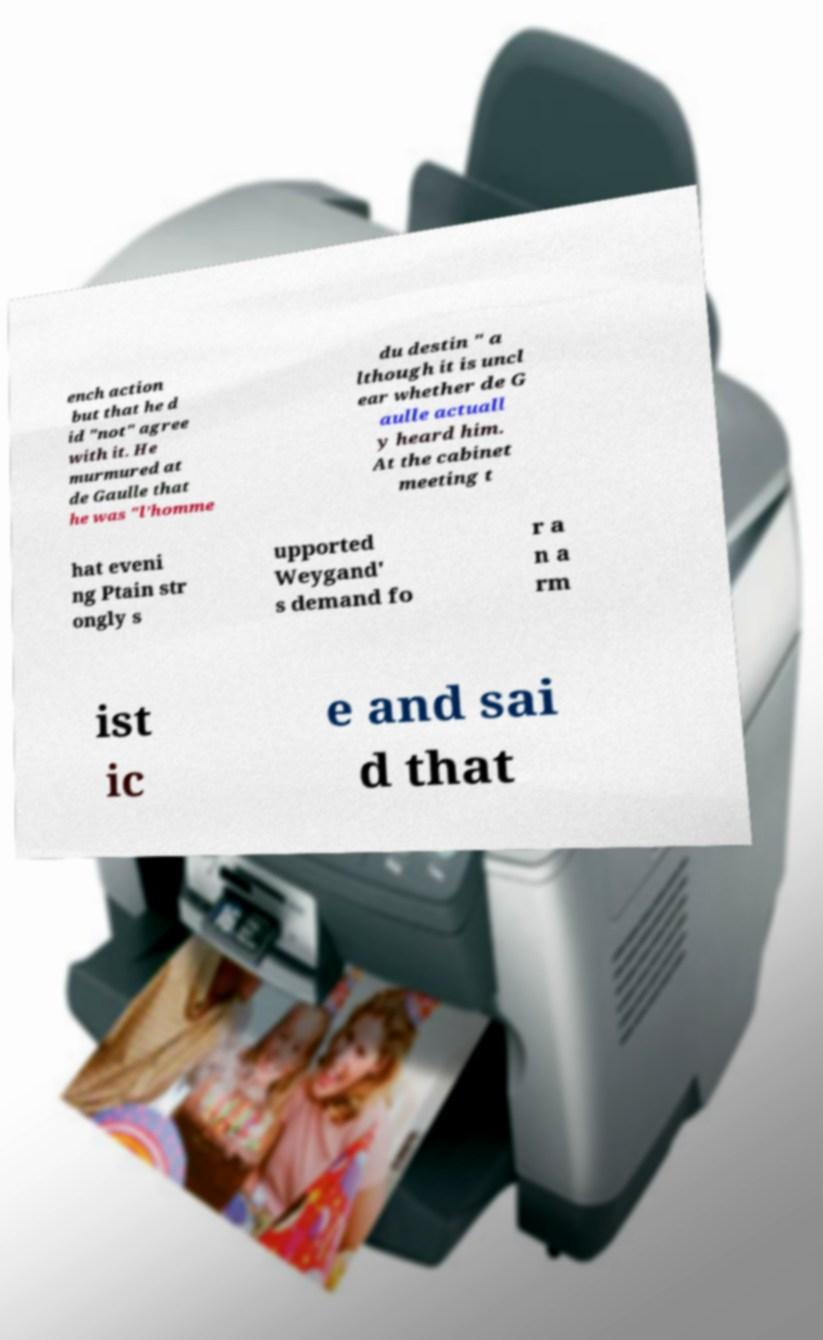Could you assist in decoding the text presented in this image and type it out clearly? ench action but that he d id "not" agree with it. He murmured at de Gaulle that he was "l’homme du destin " a lthough it is uncl ear whether de G aulle actuall y heard him. At the cabinet meeting t hat eveni ng Ptain str ongly s upported Weygand' s demand fo r a n a rm ist ic e and sai d that 